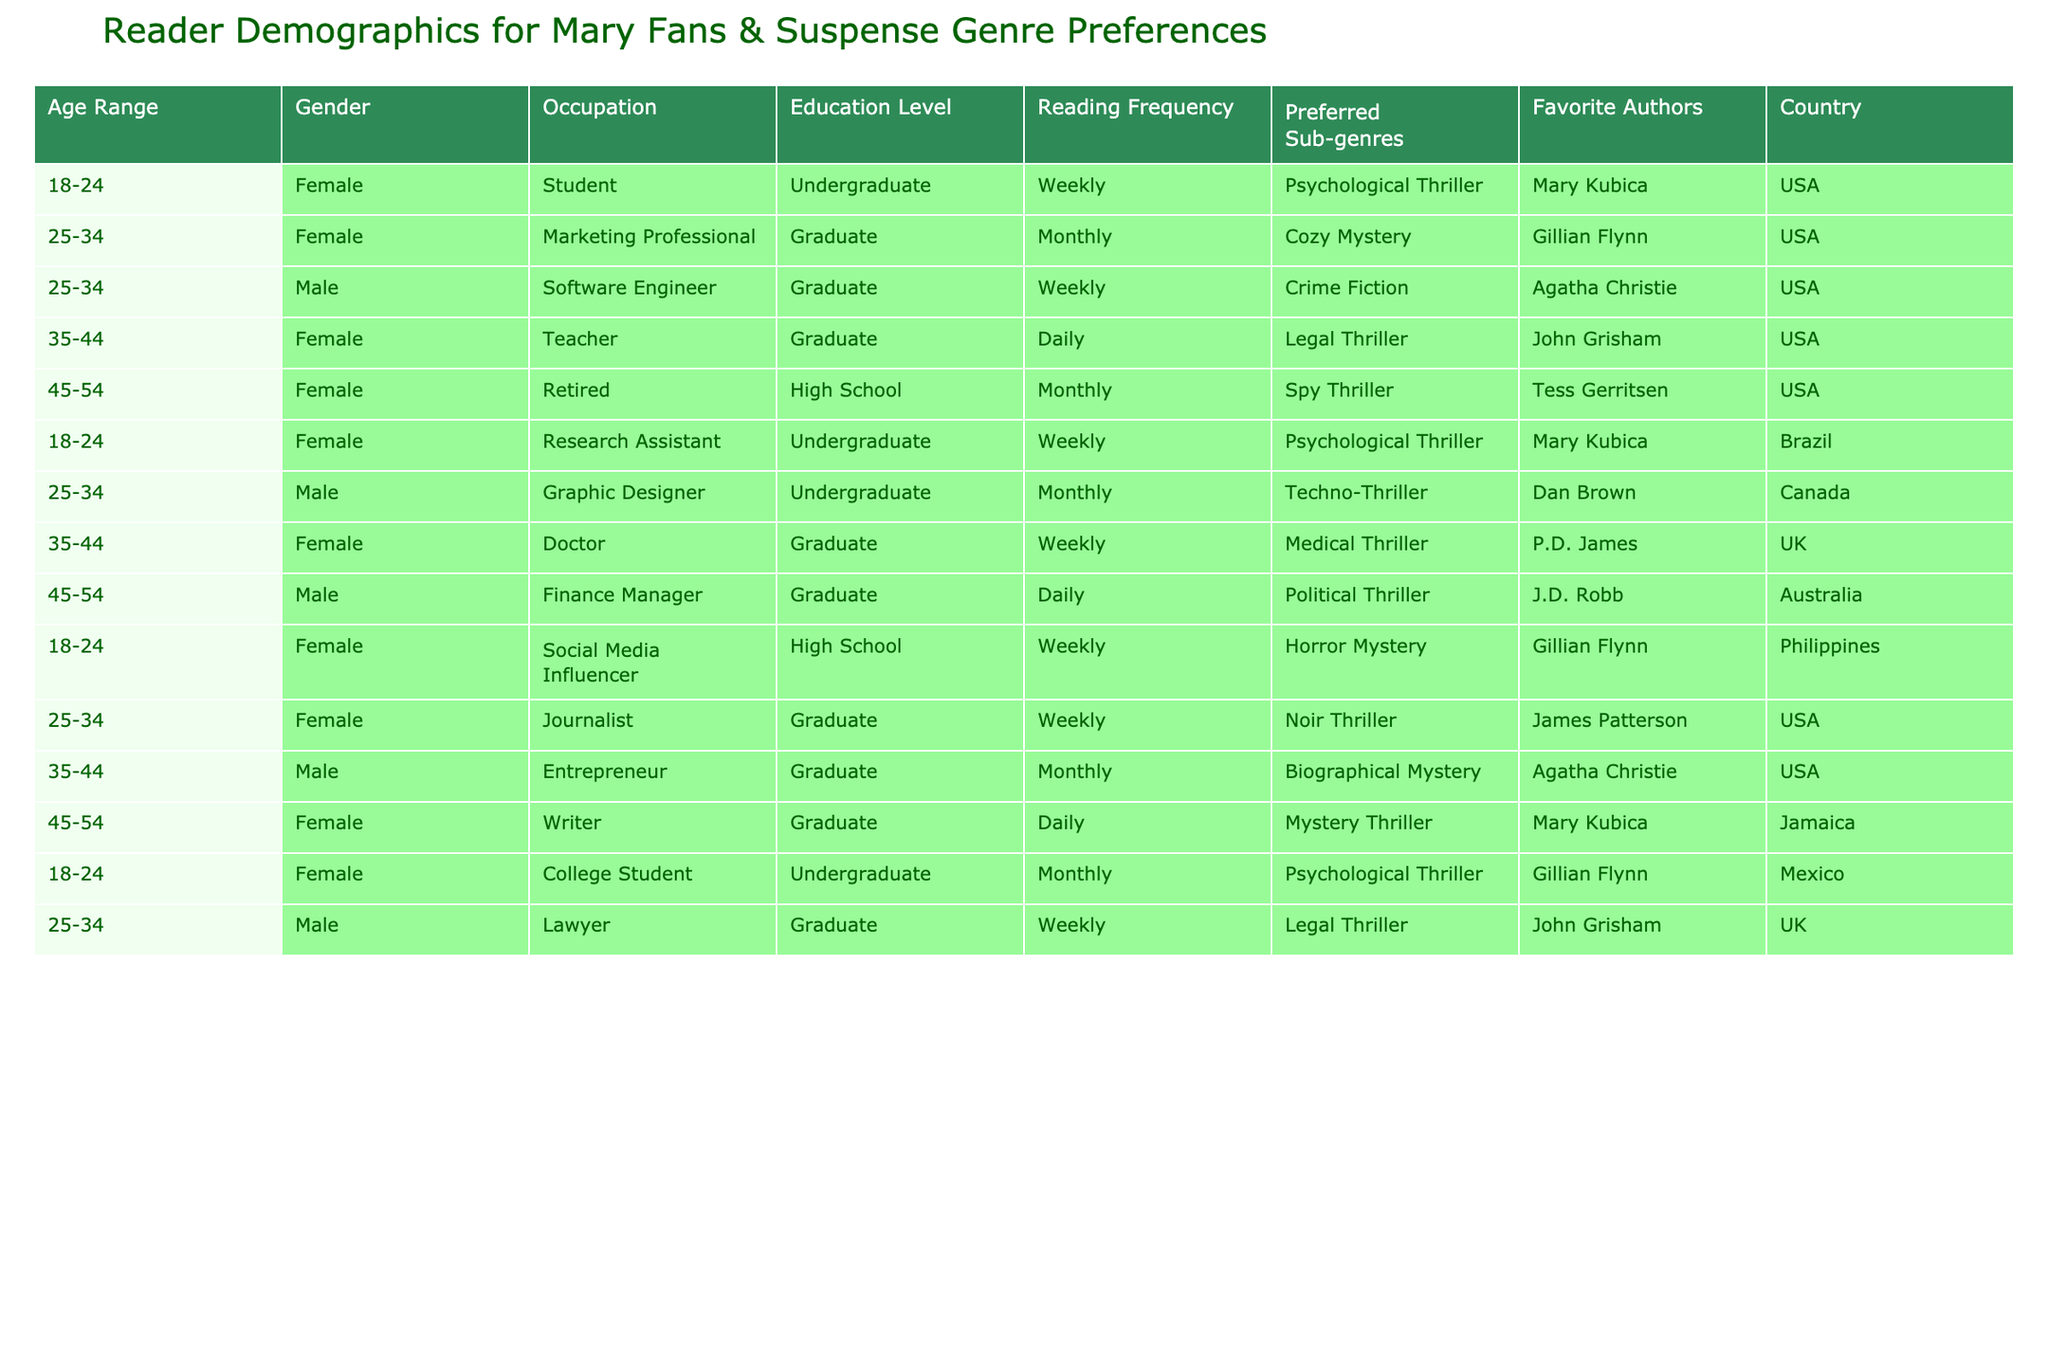What is the most common age range among readers of Mary? The data shows two age ranges: 18-24 and 25-34 both having multiple entries. However, the 18-24 age range contains the most instances (4 entries), while 25-34 has 3. Thus, 18-24 is the most common.
Answer: 18-24 Which gender has more readers in the suspense genre? By counting the entries, there are 9 females and 6 males listed in the data. Thus, females have more readers in suspense genre.
Answer: Female How many of the listed readers prefer the Psychological Thriller sub-genre? The table indicates that 4 entries specifically mention Psychological Thriller. They are in the age ranges 18-24 and 35-44 for Female readers. Thus, there are 4 readers for this sub-genre.
Answer: 4 Is there any reader who occupies the role of a teacher? By reviewing the entries in the Occupation column, there is one instance of 'Teacher' listed under the 35-44 age range, thus indicating a reader with this occupation.
Answer: Yes What is the average reading frequency among males in the dataset? To find the average, we first note the reading frequencies of the males: Weekly (3), Monthly (4). Converting these to numerical values (Daily=7, Weekly=5, Monthly=3), we have: (5 + 3 + 5 + 3) / 4 = 4. Therefore, the average reading frequency for males is 4.
Answer: 4 How many readers from the dataset prefer Cozy Mystery? By checking through the Preferred Sub-genres column, there is only one entry for Cozy Mystery, which belongs to a female marketing professional in the 25-34 age range.
Answer: 1 Do any of the readers have the same favorite author? Looking through the Favorite Authors column, both Mary Kubica and Agatha Christie appear multiple times, indicating readers share these favorites.
Answer: Yes What percentage of the total readers listed are from the USA? There are 12 readers in total, and 7 of them are from the USA. To find the percentage, we calculate (7/12) × 100 = 58.33%. Hence, about 58% of the readers are from the USA.
Answer: 58% 